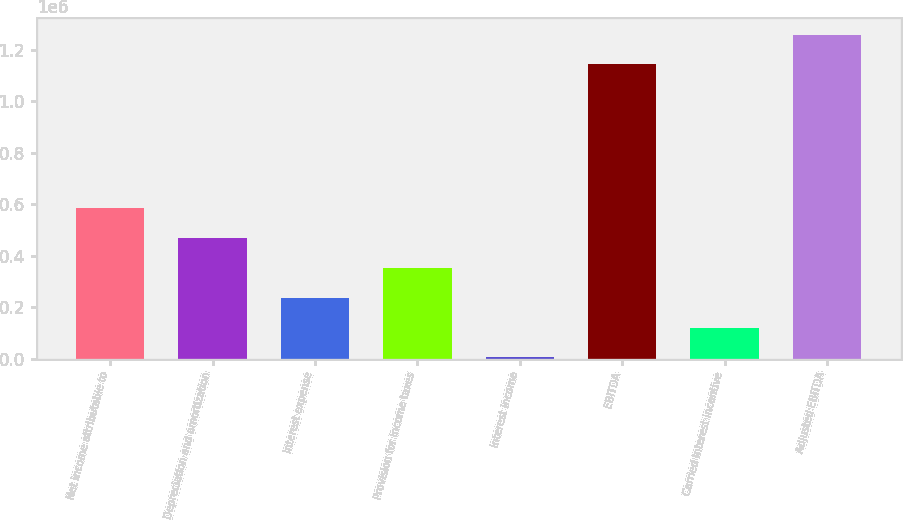Convert chart. <chart><loc_0><loc_0><loc_500><loc_500><bar_chart><fcel>Net income attributable to<fcel>Depreciation and amortization<fcel>Interest expense<fcel>Provision for income taxes<fcel>Interest income<fcel>EBITDA<fcel>Carried interest incentive<fcel>Adjusted EBITDA<nl><fcel>586179<fcel>470190<fcel>238211<fcel>354201<fcel>6233<fcel>1.14225e+06<fcel>122222<fcel>1.25824e+06<nl></chart> 